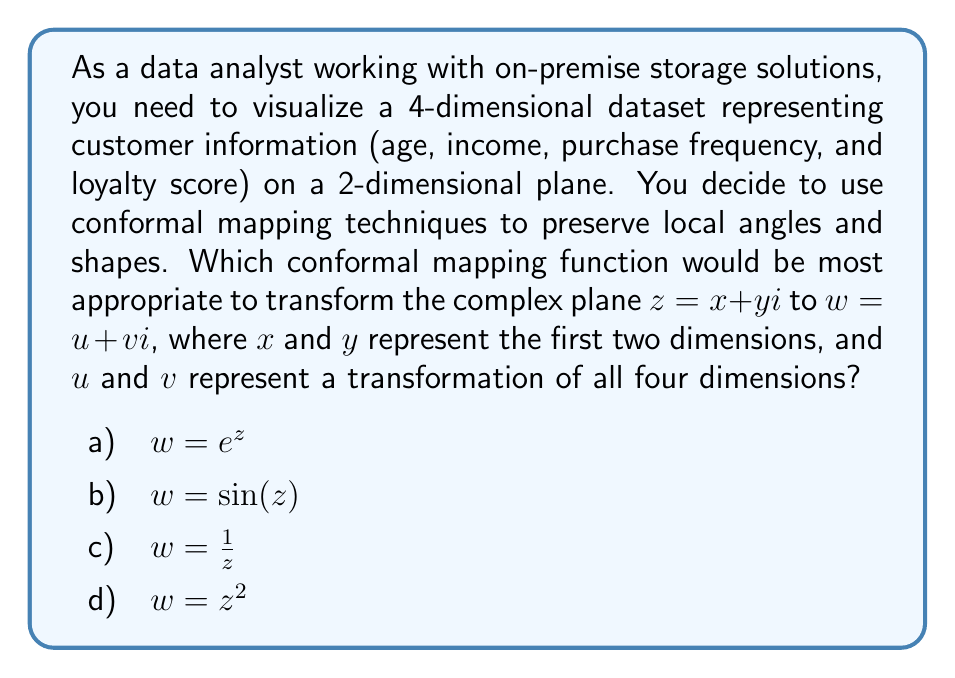Give your solution to this math problem. To address this problem, we need to consider the properties of conformal mappings and how they can be applied to visualize multidimensional data structures. Let's analyze each option:

1. $w = e^z$: The exponential function is a conformal mapping that transforms straight lines parallel to the real axis into circles centered at the origin, and lines parallel to the imaginary axis into rays emanating from the origin. This mapping has the following properties:
   - It maps the entire complex plane onto the right half-plane, excluding the imaginary axis.
   - It is periodic in the imaginary direction with period $2\pi i$.
   - It can effectively separate data points with small differences in the imaginary component.

2. $w = \sin(z)$: The sine function is a conformal mapping, but it has some limitations:
   - It is periodic in the real direction with period $2\pi$.
   - It maps the entire complex plane onto a strip of the complex plane.
   - It may not be ideal for visualizing data that doesn't have inherent periodicity.

3. $w = \frac{1}{z}$: The reciprocal function is a conformal mapping with these properties:
   - It inverts the complex plane, mapping points inside the unit circle to points outside, and vice versa.
   - It maps circles not passing through the origin to circles.
   - It may distort the relative distances between data points significantly.

4. $w = z^2$: The square function is a conformal mapping that:
   - Doubles angles at the origin.
   - Maps the entire complex plane onto itself.
   - Folds the plane along the real axis, potentially causing loss of information.

For visualizing a 4-dimensional dataset in a 2-dimensional plane, the exponential function $w = e^z$ is the most appropriate choice. Here's why:

1. It can effectively separate data points with small differences, which is crucial when dealing with multiple dimensions.
2. The periodic nature in the imaginary direction allows for wrapping of two dimensions while preserving local angles and shapes.
3. The transformation of the real part to the modulus of $w$ provides a natural way to represent the magnitude of combined dimensions.
4. It doesn't have the limitations of periodicity in both directions (like sine) or information loss due to folding (like the square function).

To apply this mapping:
- Use $x$ (age) and $y$ (income) as the real and imaginary parts of $z$.
- Transform the other two dimensions (purchase frequency and loyalty score) into a complex number and add it to $z$ before applying the exponential function.
- The resulting $u$ and $v$ coordinates will represent a transformation of all four dimensions while preserving local relationships.

This approach allows for effective visualization of the 4-dimensional data on a 2-dimensional plane, making it easier to identify patterns and clusters in the customer information stored in the on-premise solution.
Answer: a) $w = e^z$ 